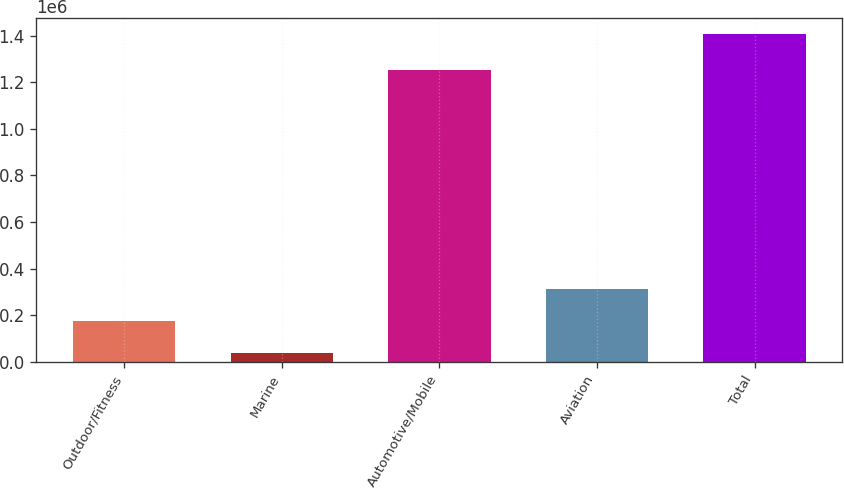Convert chart. <chart><loc_0><loc_0><loc_500><loc_500><bar_chart><fcel>Outdoor/Fitness<fcel>Marine<fcel>Automotive/Mobile<fcel>Aviation<fcel>Total<nl><fcel>173716<fcel>36760<fcel>1.25309e+06<fcel>310672<fcel>1.40632e+06<nl></chart> 